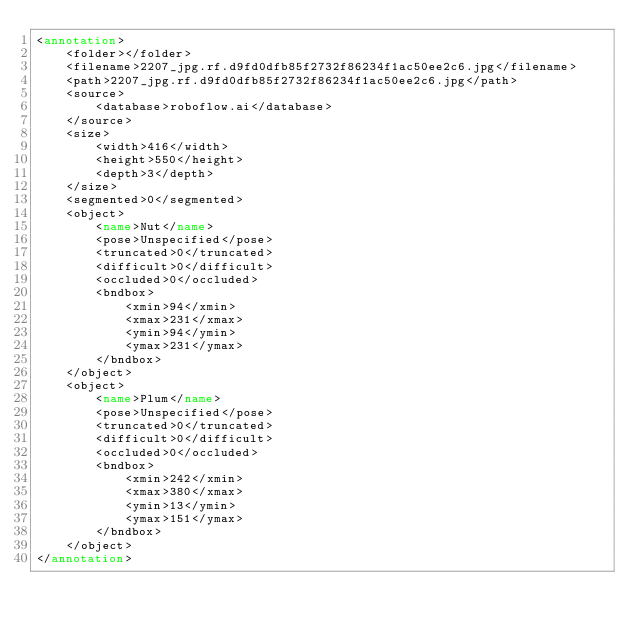Convert code to text. <code><loc_0><loc_0><loc_500><loc_500><_XML_><annotation>
	<folder></folder>
	<filename>2207_jpg.rf.d9fd0dfb85f2732f86234f1ac50ee2c6.jpg</filename>
	<path>2207_jpg.rf.d9fd0dfb85f2732f86234f1ac50ee2c6.jpg</path>
	<source>
		<database>roboflow.ai</database>
	</source>
	<size>
		<width>416</width>
		<height>550</height>
		<depth>3</depth>
	</size>
	<segmented>0</segmented>
	<object>
		<name>Nut</name>
		<pose>Unspecified</pose>
		<truncated>0</truncated>
		<difficult>0</difficult>
		<occluded>0</occluded>
		<bndbox>
			<xmin>94</xmin>
			<xmax>231</xmax>
			<ymin>94</ymin>
			<ymax>231</ymax>
		</bndbox>
	</object>
	<object>
		<name>Plum</name>
		<pose>Unspecified</pose>
		<truncated>0</truncated>
		<difficult>0</difficult>
		<occluded>0</occluded>
		<bndbox>
			<xmin>242</xmin>
			<xmax>380</xmax>
			<ymin>13</ymin>
			<ymax>151</ymax>
		</bndbox>
	</object>
</annotation>
</code> 